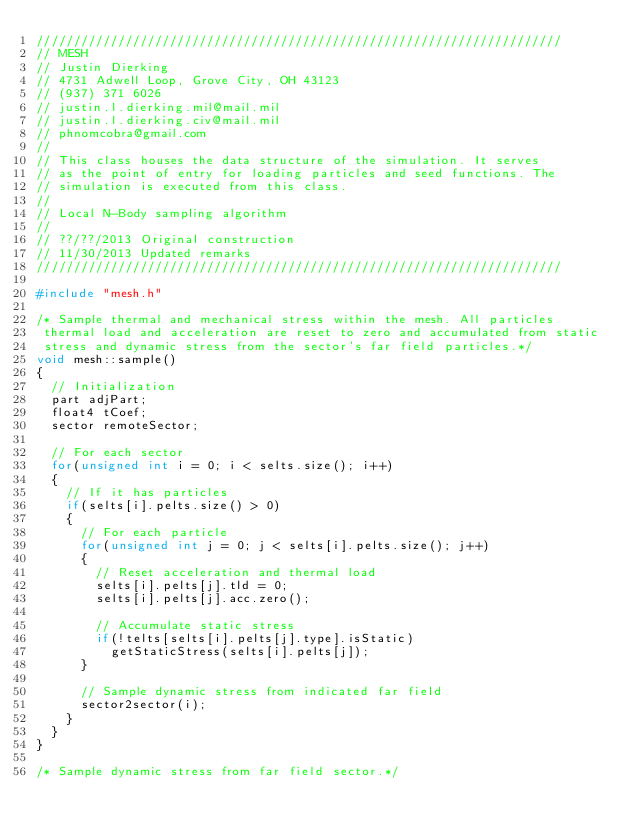<code> <loc_0><loc_0><loc_500><loc_500><_C++_>///////////////////////////////////////////////////////////////////////
// MESH
// Justin Dierking
// 4731 Adwell Loop, Grove City, OH 43123
// (937) 371 6026
// justin.l.dierking.mil@mail.mil
// justin.l.dierking.civ@mail.mil
// phnomcobra@gmail.com
//
// This class houses the data structure of the simulation. It serves
// as the point of entry for loading particles and seed functions. The
// simulation is executed from this class.
//
// Local N-Body sampling algorithm
//
// ??/??/2013 Original construction
// 11/30/2013 Updated remarks
///////////////////////////////////////////////////////////////////////

#include "mesh.h"

/* Sample thermal and mechanical stress within the mesh. All particles 
 thermal load and acceleration are reset to zero and accumulated from static
 stress and dynamic stress from the sector's far field particles.*/
void mesh::sample()
{
	// Initialization
	part adjPart;
	float4 tCoef;
	sector remoteSector;	
	
	// For each sector
	for(unsigned int i = 0; i < selts.size(); i++)
	{
		// If it has particles
		if(selts[i].pelts.size() > 0)
		{
			// For each particle
			for(unsigned int j = 0; j < selts[i].pelts.size(); j++)
			{
				// Reset acceleration and thermal load
				selts[i].pelts[j].tld = 0;
				selts[i].pelts[j].acc.zero();
				
				// Accumulate static stress
				if(!telts[selts[i].pelts[j].type].isStatic) 
					getStaticStress(selts[i].pelts[j]);
			}

			// Sample dynamic stress from indicated far field
			sector2sector(i);
		}
	}
}

/* Sample dynamic stress from far field sector.*/</code> 